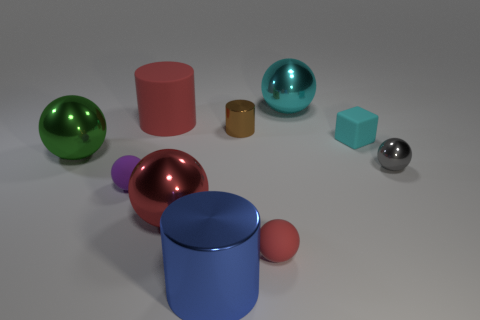Subtract all brown cylinders. How many red spheres are left? 2 Subtract all metallic cylinders. How many cylinders are left? 1 Subtract 1 balls. How many balls are left? 5 Subtract all purple spheres. How many spheres are left? 5 Subtract all red balls. Subtract all red blocks. How many balls are left? 4 Subtract 0 cyan cylinders. How many objects are left? 10 Subtract all blocks. How many objects are left? 9 Subtract all small brown cubes. Subtract all blue metal cylinders. How many objects are left? 9 Add 4 rubber things. How many rubber things are left? 8 Add 4 tiny rubber things. How many tiny rubber things exist? 7 